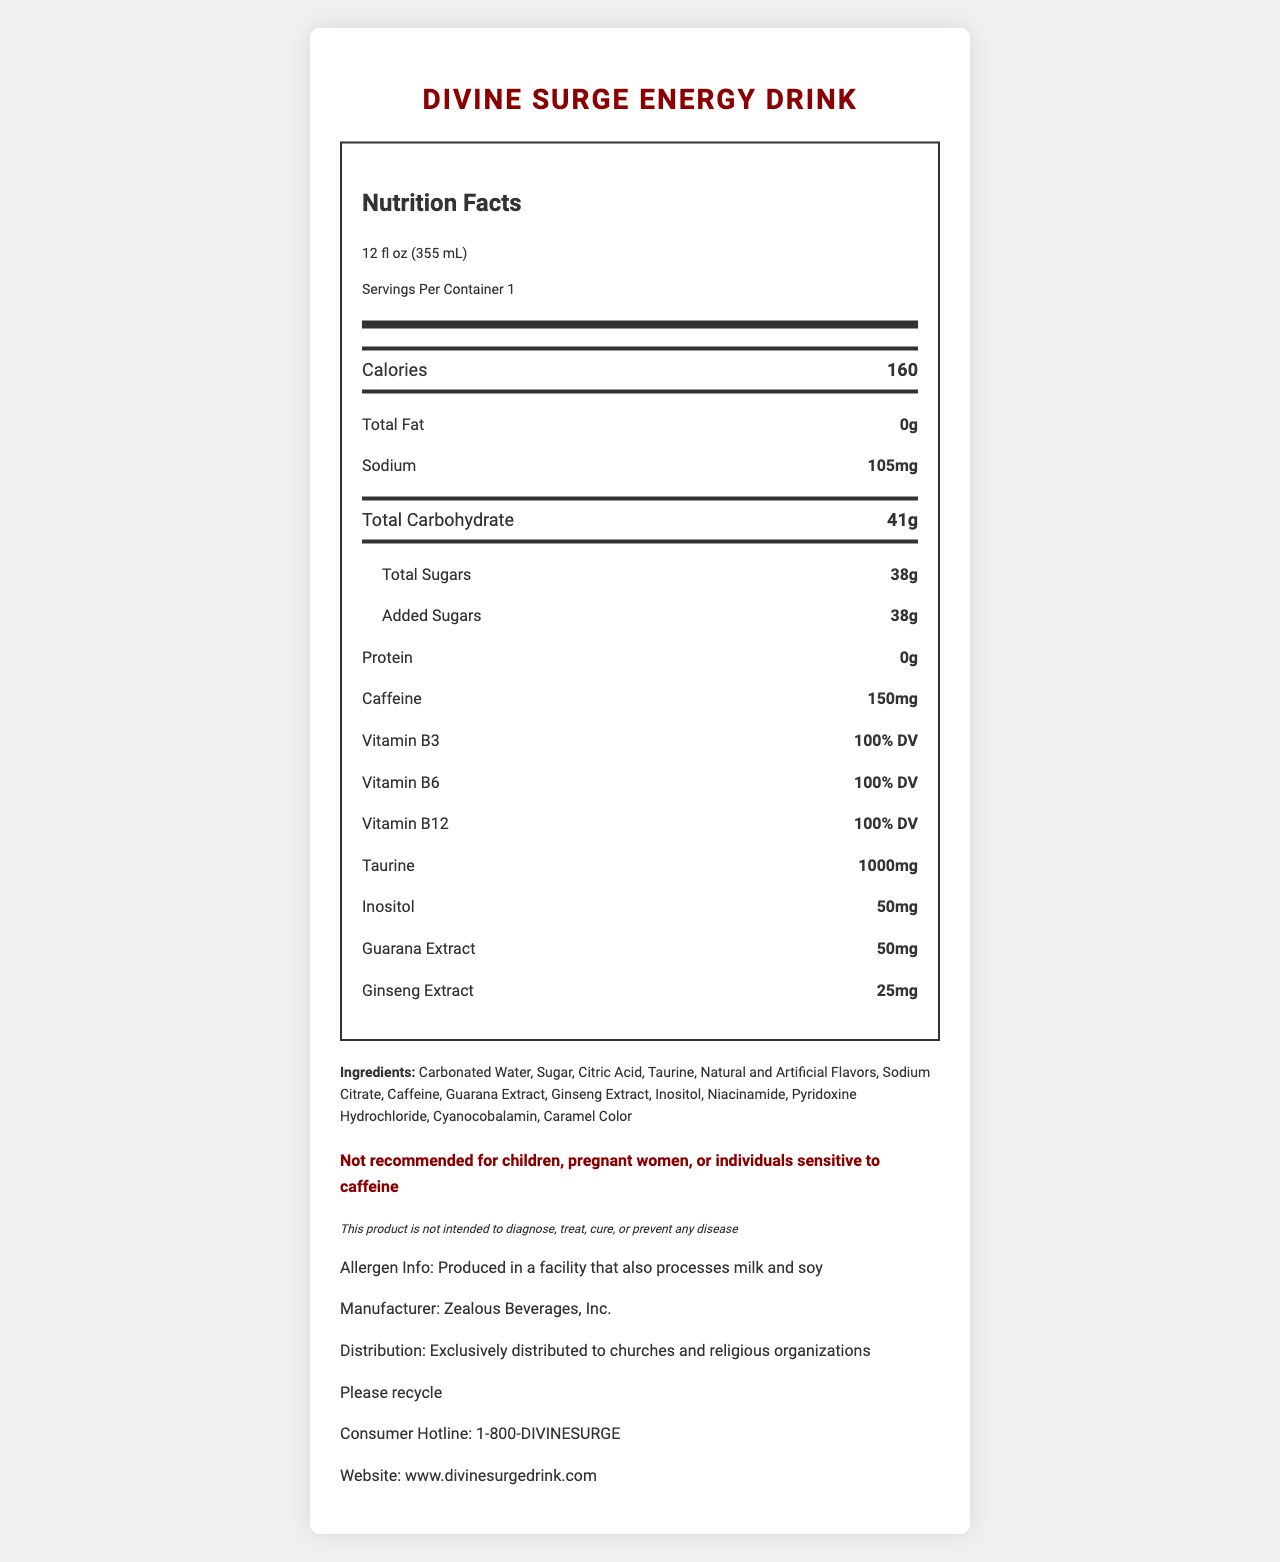What is the serving size of the energy drink? The document states that the serving size is 12 fl oz (355 mL).
Answer: 12 fl oz (355 mL) How many servings are in one container of Divine Surge Energy Drink? The document specifies that there is 1 serving per container.
Answer: 1 How much caffeine is in one serving? The document lists the caffeine content as 150mg per serving.
Answer: 150mg What is the total amount of sugars in the drink? The document shows that the total sugars content is 38 grams.
Answer: 38g List three vitamins found in Divine Surge Energy Drink. The document lists Vitamin B3, Vitamin B6, and Vitamin B12 each providing 100% DV.
Answer: Vitamin B3, Vitamin B6, Vitamin B12 How many calories are there in a single serving of this drink? The document specifies that there are 160 calories per serving.
Answer: 160 What is the sodium content in a single serving? The document lists the sodium content as 105mg.
Answer: 105mg Which of the following ingredients is NOT in Divine Surge Energy Drink? A. Taurine B. Caffeine C. High Fructose Corn Syrup D. Guarana Extract The ingredients list does not include High Fructose Corn Syrup.
Answer: C. High Fructose Corn Syrup What is the recommended daily value percentage of Vitamin B6 provided by this drink? A. 50% B. 100% C. 150% D. 200% The document indicates that the drink provides 100% of the daily value for Vitamin B6.
Answer: B. 100% Is this product recommended for children or pregnant women? The document issues a warning stating this product is not recommended for children or pregnant women.
Answer: No Summarize the main nutritional components of Divine Surge Energy Drink. The drink has various components which make it an energy-boosting beverage containing significant amounts of caffeine, vitamins, and other energizing ingredients.
Answer: Divine Surge Energy Drink contains 160 calories, 0g fat, 105mg sodium, 41g total carbohydrates including 38g sugars, and 0g protein per serving. It also contains 150mg caffeine, 100% DV of vitamins B3, B6, and B12, 1000mg taurine, 50mg inositol, 50mg guarana extract, and 25mg ginseng extract. Who manufactures Divine Surge Energy Drink? The document states that the manufacturer is Zealous Beverages, Inc.
Answer: Zealous Beverages, Inc. Where is Divine Surge Energy Drink exclusively distributed? The document clarifies that the drink is exclusively distributed to churches and religious organizations.
Answer: Churches and religious organizations What allergen information is provided on the label? The allergen info section states that the drink is produced in a facility that processes milk and soy.
Answer: Produced in a facility that also processes milk and soy What is the consumer hotline for Divine Surge Energy Drink? The document lists the consumer hotline as 1-800-DIVINESURGE.
Answer: 1-800-DIVINESURGE How much inositol does Divine Surge Energy Drink contain? The document mentions that the drink contains 50mg of inositol.
Answer: 50mg What flavors does this energy drink have? The document mentions "Natural and Artificial Flavors" but does not specify what flavors are present.
Answer: Cannot be determined What is the recycling message given on the document? The document includes a note encouraging consumers to recycle with the message, "Please recycle".
Answer: Please recycle What color is the nutritional information label? The document describes the content but does not provide visual information about the color of the label.
Answer: Not enough information 